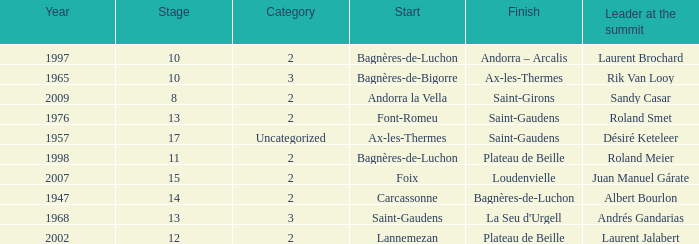Give the Finish for a Stage that is larger than 15 Saint-Gaudens. 